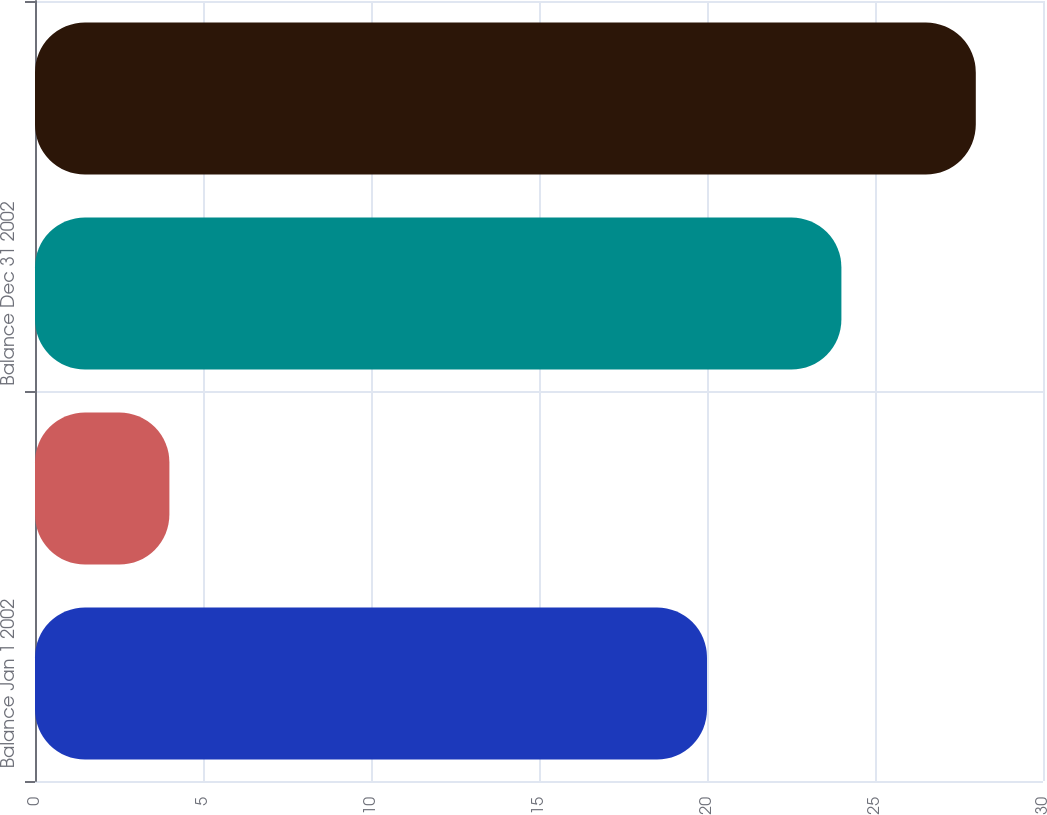Convert chart. <chart><loc_0><loc_0><loc_500><loc_500><bar_chart><fcel>Balance Jan 1 2002<fcel>Currency translation<fcel>Balance Dec 31 2002<fcel>Balance Dec 31 2003<nl><fcel>20<fcel>4<fcel>24<fcel>28<nl></chart> 